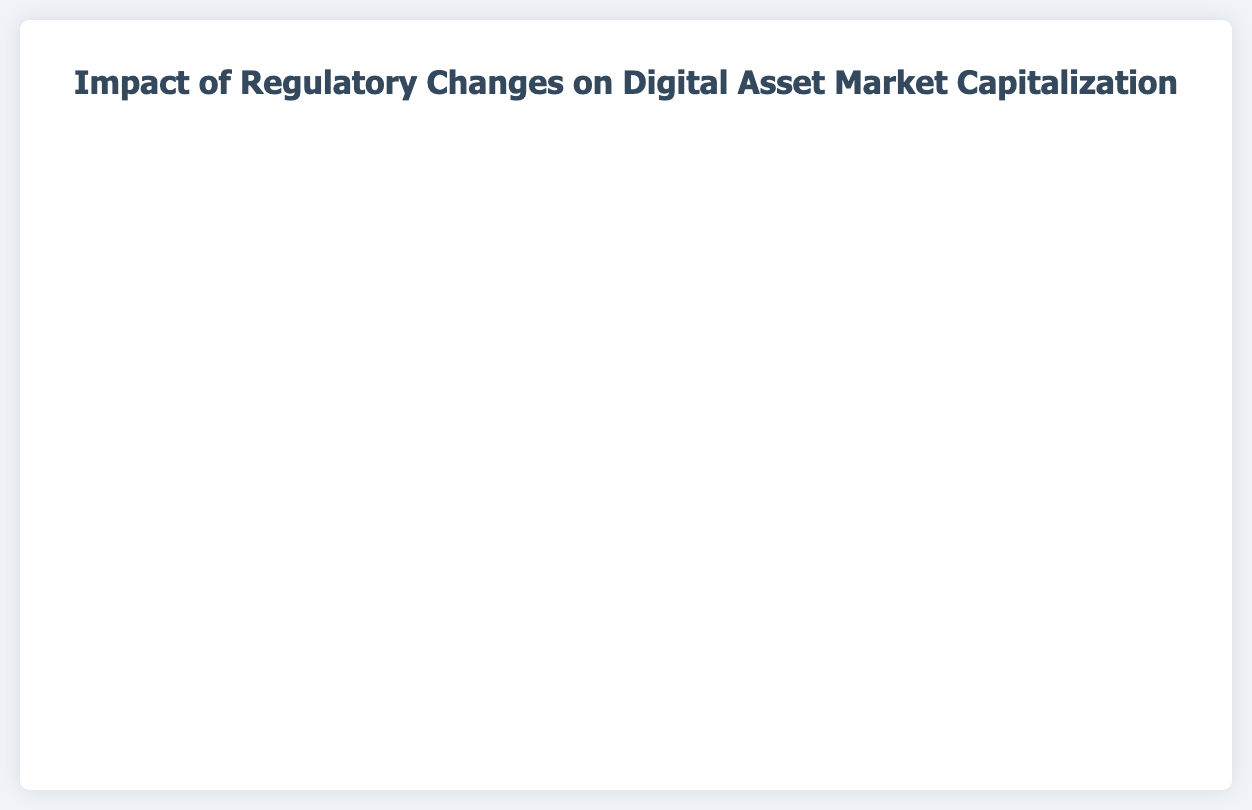Which event had the most significant negative impact on market capitalization? By looking at the figure, we can see the lowest point with the highest negative market impact. The event "China Declares All Cryptocurrency Transactions Illegal" has the most significant negative impact indicated by the lowest point on the chart.
Answer: China Declares All Cryptocurrency Transactions Illegal How many events had a positive impact on market capitalization? By counting the points that are above the zero line on the y-axis in the figure, we can see that there are 8 events that had a positive impact.
Answer: 8 What is the average market cap impact of negative regulatory events? First, identify the negative impacts: -20.5, -15.2, -8.1, -18.0, -30.2, -23.7, -5.6. Sum these values and divide by the number of events: (-20.5 - 15.2 - 8.1 - 18.0 - 30.2 - 23.7 - 5.6) / 7 = -121.3 / 7 = -17.33.
Answer: -17.33 Which event corresponds to the highest positive market cap impact? By identifying the highest point on the chart, we can see that the "El Salvador Adopts Bitcoin as Legal Tender" event corresponds to the highest positive market cap impact.
Answer: El Salvador Adopts Bitcoin as Legal Tender Compare the market cap impacts of "China Bans ICOs" and "U.S. Executive Order on Digital Assets." Which had a greater impact? By comparing the points on the chart for these events, "China Bans ICOs" had an impact of -20.5, whereas "U.S. Executive Order on Digital Assets" had an impact of 14.6. The negative impact of -20.5 is greater in magnitude than the positive impact of 14.6.
Answer: China Bans ICOs What was the market cap impact on average for events in the year 2021? For the year 2021, the impacts are -18.0 (May 12), 25.4 (June 9), and -30.2 (September 24). Calculate the average: (-18.0 + 25.4 - 30.2) / 3 = -22.8 / 3 = -7.6.
Answer: -7.6 Was the overall market cap impact positive or negative from 2018 to 2023? Sum all the percentage impacts from the given events: -20.5 - 15.2 + 5.7 + 10.3 - 8.1 + 12.8 - 18.0 + 25.4 - 30.2 + 7.5 + 14.6 + 11.2 - 23.7 - 5.6 + 9.3 = -24.4. The overall impact is negative.
Answer: Negative 